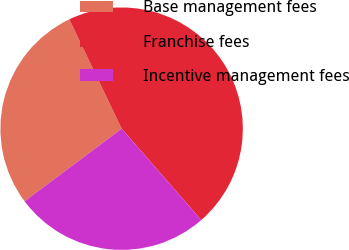Convert chart. <chart><loc_0><loc_0><loc_500><loc_500><pie_chart><fcel>Base management fees<fcel>Franchise fees<fcel>Incentive management fees<nl><fcel>28.13%<fcel>45.69%<fcel>26.18%<nl></chart> 